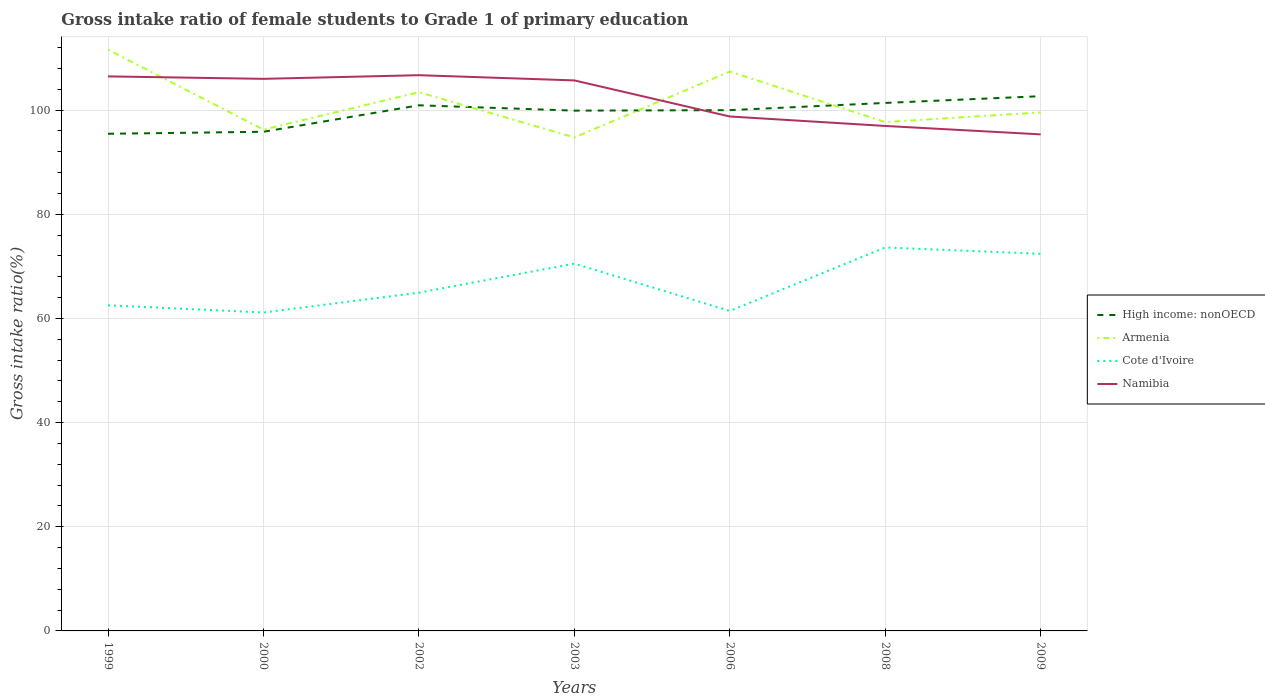How many different coloured lines are there?
Your answer should be compact. 4. Across all years, what is the maximum gross intake ratio in Namibia?
Provide a short and direct response. 95.34. In which year was the gross intake ratio in Cote d'Ivoire maximum?
Provide a short and direct response. 2000. What is the total gross intake ratio in Armenia in the graph?
Your answer should be compact. -3.97. What is the difference between the highest and the second highest gross intake ratio in High income: nonOECD?
Keep it short and to the point. 7.22. Is the gross intake ratio in Armenia strictly greater than the gross intake ratio in Cote d'Ivoire over the years?
Offer a very short reply. No. How many years are there in the graph?
Your answer should be compact. 7. What is the difference between two consecutive major ticks on the Y-axis?
Keep it short and to the point. 20. Are the values on the major ticks of Y-axis written in scientific E-notation?
Ensure brevity in your answer.  No. Does the graph contain any zero values?
Ensure brevity in your answer.  No. Does the graph contain grids?
Make the answer very short. Yes. Where does the legend appear in the graph?
Ensure brevity in your answer.  Center right. How many legend labels are there?
Ensure brevity in your answer.  4. What is the title of the graph?
Provide a short and direct response. Gross intake ratio of female students to Grade 1 of primary education. Does "Latin America(developing only)" appear as one of the legend labels in the graph?
Give a very brief answer. No. What is the label or title of the X-axis?
Make the answer very short. Years. What is the label or title of the Y-axis?
Your response must be concise. Gross intake ratio(%). What is the Gross intake ratio(%) in High income: nonOECD in 1999?
Provide a succinct answer. 95.45. What is the Gross intake ratio(%) of Armenia in 1999?
Ensure brevity in your answer.  111.59. What is the Gross intake ratio(%) in Cote d'Ivoire in 1999?
Your answer should be compact. 62.52. What is the Gross intake ratio(%) in Namibia in 1999?
Offer a very short reply. 106.47. What is the Gross intake ratio(%) in High income: nonOECD in 2000?
Provide a short and direct response. 95.84. What is the Gross intake ratio(%) in Armenia in 2000?
Ensure brevity in your answer.  96.25. What is the Gross intake ratio(%) of Cote d'Ivoire in 2000?
Offer a terse response. 61.14. What is the Gross intake ratio(%) of Namibia in 2000?
Offer a very short reply. 106. What is the Gross intake ratio(%) in High income: nonOECD in 2002?
Your response must be concise. 100.92. What is the Gross intake ratio(%) in Armenia in 2002?
Give a very brief answer. 103.44. What is the Gross intake ratio(%) of Cote d'Ivoire in 2002?
Ensure brevity in your answer.  64.95. What is the Gross intake ratio(%) of Namibia in 2002?
Your answer should be very brief. 106.7. What is the Gross intake ratio(%) in High income: nonOECD in 2003?
Your response must be concise. 99.9. What is the Gross intake ratio(%) in Armenia in 2003?
Your response must be concise. 94.75. What is the Gross intake ratio(%) in Cote d'Ivoire in 2003?
Your response must be concise. 70.52. What is the Gross intake ratio(%) in Namibia in 2003?
Offer a very short reply. 105.7. What is the Gross intake ratio(%) in High income: nonOECD in 2006?
Your answer should be compact. 99.99. What is the Gross intake ratio(%) in Armenia in 2006?
Offer a terse response. 107.41. What is the Gross intake ratio(%) of Cote d'Ivoire in 2006?
Give a very brief answer. 61.44. What is the Gross intake ratio(%) of Namibia in 2006?
Make the answer very short. 98.77. What is the Gross intake ratio(%) in High income: nonOECD in 2008?
Ensure brevity in your answer.  101.38. What is the Gross intake ratio(%) in Armenia in 2008?
Provide a short and direct response. 97.7. What is the Gross intake ratio(%) of Cote d'Ivoire in 2008?
Your answer should be compact. 73.63. What is the Gross intake ratio(%) in Namibia in 2008?
Your answer should be compact. 96.95. What is the Gross intake ratio(%) in High income: nonOECD in 2009?
Keep it short and to the point. 102.67. What is the Gross intake ratio(%) of Armenia in 2009?
Ensure brevity in your answer.  99.56. What is the Gross intake ratio(%) in Cote d'Ivoire in 2009?
Offer a terse response. 72.4. What is the Gross intake ratio(%) in Namibia in 2009?
Keep it short and to the point. 95.34. Across all years, what is the maximum Gross intake ratio(%) in High income: nonOECD?
Make the answer very short. 102.67. Across all years, what is the maximum Gross intake ratio(%) of Armenia?
Your response must be concise. 111.59. Across all years, what is the maximum Gross intake ratio(%) in Cote d'Ivoire?
Your answer should be very brief. 73.63. Across all years, what is the maximum Gross intake ratio(%) of Namibia?
Provide a succinct answer. 106.7. Across all years, what is the minimum Gross intake ratio(%) of High income: nonOECD?
Provide a succinct answer. 95.45. Across all years, what is the minimum Gross intake ratio(%) in Armenia?
Offer a terse response. 94.75. Across all years, what is the minimum Gross intake ratio(%) in Cote d'Ivoire?
Your answer should be very brief. 61.14. Across all years, what is the minimum Gross intake ratio(%) of Namibia?
Make the answer very short. 95.34. What is the total Gross intake ratio(%) in High income: nonOECD in the graph?
Ensure brevity in your answer.  696.15. What is the total Gross intake ratio(%) in Armenia in the graph?
Make the answer very short. 710.7. What is the total Gross intake ratio(%) of Cote d'Ivoire in the graph?
Your answer should be very brief. 466.6. What is the total Gross intake ratio(%) of Namibia in the graph?
Offer a very short reply. 715.94. What is the difference between the Gross intake ratio(%) in High income: nonOECD in 1999 and that in 2000?
Keep it short and to the point. -0.39. What is the difference between the Gross intake ratio(%) of Armenia in 1999 and that in 2000?
Give a very brief answer. 15.34. What is the difference between the Gross intake ratio(%) of Cote d'Ivoire in 1999 and that in 2000?
Your answer should be very brief. 1.39. What is the difference between the Gross intake ratio(%) of Namibia in 1999 and that in 2000?
Give a very brief answer. 0.47. What is the difference between the Gross intake ratio(%) of High income: nonOECD in 1999 and that in 2002?
Your answer should be compact. -5.47. What is the difference between the Gross intake ratio(%) of Armenia in 1999 and that in 2002?
Provide a short and direct response. 8.15. What is the difference between the Gross intake ratio(%) in Cote d'Ivoire in 1999 and that in 2002?
Keep it short and to the point. -2.42. What is the difference between the Gross intake ratio(%) in Namibia in 1999 and that in 2002?
Ensure brevity in your answer.  -0.23. What is the difference between the Gross intake ratio(%) in High income: nonOECD in 1999 and that in 2003?
Give a very brief answer. -4.44. What is the difference between the Gross intake ratio(%) of Armenia in 1999 and that in 2003?
Make the answer very short. 16.84. What is the difference between the Gross intake ratio(%) of Cote d'Ivoire in 1999 and that in 2003?
Ensure brevity in your answer.  -8. What is the difference between the Gross intake ratio(%) in Namibia in 1999 and that in 2003?
Your response must be concise. 0.77. What is the difference between the Gross intake ratio(%) in High income: nonOECD in 1999 and that in 2006?
Give a very brief answer. -4.54. What is the difference between the Gross intake ratio(%) in Armenia in 1999 and that in 2006?
Your response must be concise. 4.19. What is the difference between the Gross intake ratio(%) of Cote d'Ivoire in 1999 and that in 2006?
Offer a terse response. 1.08. What is the difference between the Gross intake ratio(%) in Namibia in 1999 and that in 2006?
Provide a succinct answer. 7.7. What is the difference between the Gross intake ratio(%) of High income: nonOECD in 1999 and that in 2008?
Provide a succinct answer. -5.92. What is the difference between the Gross intake ratio(%) in Armenia in 1999 and that in 2008?
Give a very brief answer. 13.89. What is the difference between the Gross intake ratio(%) of Cote d'Ivoire in 1999 and that in 2008?
Give a very brief answer. -11.1. What is the difference between the Gross intake ratio(%) in Namibia in 1999 and that in 2008?
Provide a succinct answer. 9.52. What is the difference between the Gross intake ratio(%) in High income: nonOECD in 1999 and that in 2009?
Give a very brief answer. -7.22. What is the difference between the Gross intake ratio(%) in Armenia in 1999 and that in 2009?
Ensure brevity in your answer.  12.04. What is the difference between the Gross intake ratio(%) of Cote d'Ivoire in 1999 and that in 2009?
Ensure brevity in your answer.  -9.88. What is the difference between the Gross intake ratio(%) in Namibia in 1999 and that in 2009?
Provide a succinct answer. 11.13. What is the difference between the Gross intake ratio(%) in High income: nonOECD in 2000 and that in 2002?
Your answer should be very brief. -5.08. What is the difference between the Gross intake ratio(%) in Armenia in 2000 and that in 2002?
Provide a succinct answer. -7.19. What is the difference between the Gross intake ratio(%) of Cote d'Ivoire in 2000 and that in 2002?
Offer a very short reply. -3.81. What is the difference between the Gross intake ratio(%) in Namibia in 2000 and that in 2002?
Your answer should be compact. -0.7. What is the difference between the Gross intake ratio(%) of High income: nonOECD in 2000 and that in 2003?
Keep it short and to the point. -4.06. What is the difference between the Gross intake ratio(%) in Armenia in 2000 and that in 2003?
Your answer should be very brief. 1.5. What is the difference between the Gross intake ratio(%) in Cote d'Ivoire in 2000 and that in 2003?
Your answer should be very brief. -9.39. What is the difference between the Gross intake ratio(%) of Namibia in 2000 and that in 2003?
Your response must be concise. 0.3. What is the difference between the Gross intake ratio(%) in High income: nonOECD in 2000 and that in 2006?
Provide a short and direct response. -4.15. What is the difference between the Gross intake ratio(%) of Armenia in 2000 and that in 2006?
Keep it short and to the point. -11.15. What is the difference between the Gross intake ratio(%) of Cote d'Ivoire in 2000 and that in 2006?
Give a very brief answer. -0.31. What is the difference between the Gross intake ratio(%) in Namibia in 2000 and that in 2006?
Provide a short and direct response. 7.23. What is the difference between the Gross intake ratio(%) of High income: nonOECD in 2000 and that in 2008?
Your answer should be compact. -5.54. What is the difference between the Gross intake ratio(%) in Armenia in 2000 and that in 2008?
Make the answer very short. -1.45. What is the difference between the Gross intake ratio(%) of Cote d'Ivoire in 2000 and that in 2008?
Make the answer very short. -12.49. What is the difference between the Gross intake ratio(%) of Namibia in 2000 and that in 2008?
Your answer should be very brief. 9.05. What is the difference between the Gross intake ratio(%) in High income: nonOECD in 2000 and that in 2009?
Your response must be concise. -6.83. What is the difference between the Gross intake ratio(%) in Armenia in 2000 and that in 2009?
Your response must be concise. -3.3. What is the difference between the Gross intake ratio(%) in Cote d'Ivoire in 2000 and that in 2009?
Provide a succinct answer. -11.27. What is the difference between the Gross intake ratio(%) in Namibia in 2000 and that in 2009?
Provide a succinct answer. 10.66. What is the difference between the Gross intake ratio(%) in High income: nonOECD in 2002 and that in 2003?
Offer a very short reply. 1.02. What is the difference between the Gross intake ratio(%) in Armenia in 2002 and that in 2003?
Give a very brief answer. 8.69. What is the difference between the Gross intake ratio(%) of Cote d'Ivoire in 2002 and that in 2003?
Provide a succinct answer. -5.58. What is the difference between the Gross intake ratio(%) in High income: nonOECD in 2002 and that in 2006?
Make the answer very short. 0.93. What is the difference between the Gross intake ratio(%) in Armenia in 2002 and that in 2006?
Give a very brief answer. -3.97. What is the difference between the Gross intake ratio(%) of Cote d'Ivoire in 2002 and that in 2006?
Make the answer very short. 3.5. What is the difference between the Gross intake ratio(%) of Namibia in 2002 and that in 2006?
Offer a very short reply. 7.93. What is the difference between the Gross intake ratio(%) in High income: nonOECD in 2002 and that in 2008?
Your answer should be compact. -0.45. What is the difference between the Gross intake ratio(%) of Armenia in 2002 and that in 2008?
Your answer should be very brief. 5.74. What is the difference between the Gross intake ratio(%) of Cote d'Ivoire in 2002 and that in 2008?
Your answer should be compact. -8.68. What is the difference between the Gross intake ratio(%) in Namibia in 2002 and that in 2008?
Keep it short and to the point. 9.75. What is the difference between the Gross intake ratio(%) of High income: nonOECD in 2002 and that in 2009?
Offer a terse response. -1.75. What is the difference between the Gross intake ratio(%) of Armenia in 2002 and that in 2009?
Your answer should be compact. 3.89. What is the difference between the Gross intake ratio(%) in Cote d'Ivoire in 2002 and that in 2009?
Offer a terse response. -7.46. What is the difference between the Gross intake ratio(%) of Namibia in 2002 and that in 2009?
Your answer should be compact. 11.36. What is the difference between the Gross intake ratio(%) of High income: nonOECD in 2003 and that in 2006?
Provide a short and direct response. -0.09. What is the difference between the Gross intake ratio(%) in Armenia in 2003 and that in 2006?
Your answer should be compact. -12.66. What is the difference between the Gross intake ratio(%) in Cote d'Ivoire in 2003 and that in 2006?
Your answer should be very brief. 9.08. What is the difference between the Gross intake ratio(%) of Namibia in 2003 and that in 2006?
Ensure brevity in your answer.  6.93. What is the difference between the Gross intake ratio(%) in High income: nonOECD in 2003 and that in 2008?
Your response must be concise. -1.48. What is the difference between the Gross intake ratio(%) of Armenia in 2003 and that in 2008?
Your answer should be compact. -2.95. What is the difference between the Gross intake ratio(%) of Cote d'Ivoire in 2003 and that in 2008?
Your answer should be compact. -3.1. What is the difference between the Gross intake ratio(%) in Namibia in 2003 and that in 2008?
Keep it short and to the point. 8.74. What is the difference between the Gross intake ratio(%) in High income: nonOECD in 2003 and that in 2009?
Give a very brief answer. -2.77. What is the difference between the Gross intake ratio(%) in Armenia in 2003 and that in 2009?
Provide a succinct answer. -4.81. What is the difference between the Gross intake ratio(%) of Cote d'Ivoire in 2003 and that in 2009?
Give a very brief answer. -1.88. What is the difference between the Gross intake ratio(%) of Namibia in 2003 and that in 2009?
Your response must be concise. 10.36. What is the difference between the Gross intake ratio(%) in High income: nonOECD in 2006 and that in 2008?
Offer a terse response. -1.39. What is the difference between the Gross intake ratio(%) of Armenia in 2006 and that in 2008?
Make the answer very short. 9.71. What is the difference between the Gross intake ratio(%) of Cote d'Ivoire in 2006 and that in 2008?
Ensure brevity in your answer.  -12.18. What is the difference between the Gross intake ratio(%) of Namibia in 2006 and that in 2008?
Your response must be concise. 1.82. What is the difference between the Gross intake ratio(%) in High income: nonOECD in 2006 and that in 2009?
Provide a succinct answer. -2.68. What is the difference between the Gross intake ratio(%) in Armenia in 2006 and that in 2009?
Offer a very short reply. 7.85. What is the difference between the Gross intake ratio(%) of Cote d'Ivoire in 2006 and that in 2009?
Your response must be concise. -10.96. What is the difference between the Gross intake ratio(%) in Namibia in 2006 and that in 2009?
Provide a short and direct response. 3.43. What is the difference between the Gross intake ratio(%) of High income: nonOECD in 2008 and that in 2009?
Ensure brevity in your answer.  -1.29. What is the difference between the Gross intake ratio(%) of Armenia in 2008 and that in 2009?
Your answer should be compact. -1.85. What is the difference between the Gross intake ratio(%) in Cote d'Ivoire in 2008 and that in 2009?
Give a very brief answer. 1.22. What is the difference between the Gross intake ratio(%) of Namibia in 2008 and that in 2009?
Your response must be concise. 1.62. What is the difference between the Gross intake ratio(%) of High income: nonOECD in 1999 and the Gross intake ratio(%) of Armenia in 2000?
Your answer should be compact. -0.8. What is the difference between the Gross intake ratio(%) in High income: nonOECD in 1999 and the Gross intake ratio(%) in Cote d'Ivoire in 2000?
Your answer should be very brief. 34.32. What is the difference between the Gross intake ratio(%) in High income: nonOECD in 1999 and the Gross intake ratio(%) in Namibia in 2000?
Your answer should be compact. -10.55. What is the difference between the Gross intake ratio(%) in Armenia in 1999 and the Gross intake ratio(%) in Cote d'Ivoire in 2000?
Your answer should be very brief. 50.46. What is the difference between the Gross intake ratio(%) of Armenia in 1999 and the Gross intake ratio(%) of Namibia in 2000?
Offer a very short reply. 5.59. What is the difference between the Gross intake ratio(%) in Cote d'Ivoire in 1999 and the Gross intake ratio(%) in Namibia in 2000?
Provide a succinct answer. -43.48. What is the difference between the Gross intake ratio(%) in High income: nonOECD in 1999 and the Gross intake ratio(%) in Armenia in 2002?
Your answer should be very brief. -7.99. What is the difference between the Gross intake ratio(%) of High income: nonOECD in 1999 and the Gross intake ratio(%) of Cote d'Ivoire in 2002?
Provide a short and direct response. 30.51. What is the difference between the Gross intake ratio(%) of High income: nonOECD in 1999 and the Gross intake ratio(%) of Namibia in 2002?
Offer a very short reply. -11.25. What is the difference between the Gross intake ratio(%) in Armenia in 1999 and the Gross intake ratio(%) in Cote d'Ivoire in 2002?
Offer a very short reply. 46.65. What is the difference between the Gross intake ratio(%) in Armenia in 1999 and the Gross intake ratio(%) in Namibia in 2002?
Provide a short and direct response. 4.89. What is the difference between the Gross intake ratio(%) in Cote d'Ivoire in 1999 and the Gross intake ratio(%) in Namibia in 2002?
Make the answer very short. -44.18. What is the difference between the Gross intake ratio(%) of High income: nonOECD in 1999 and the Gross intake ratio(%) of Armenia in 2003?
Your response must be concise. 0.7. What is the difference between the Gross intake ratio(%) in High income: nonOECD in 1999 and the Gross intake ratio(%) in Cote d'Ivoire in 2003?
Your answer should be compact. 24.93. What is the difference between the Gross intake ratio(%) of High income: nonOECD in 1999 and the Gross intake ratio(%) of Namibia in 2003?
Your answer should be compact. -10.25. What is the difference between the Gross intake ratio(%) of Armenia in 1999 and the Gross intake ratio(%) of Cote d'Ivoire in 2003?
Offer a terse response. 41.07. What is the difference between the Gross intake ratio(%) of Armenia in 1999 and the Gross intake ratio(%) of Namibia in 2003?
Provide a succinct answer. 5.89. What is the difference between the Gross intake ratio(%) of Cote d'Ivoire in 1999 and the Gross intake ratio(%) of Namibia in 2003?
Provide a short and direct response. -43.18. What is the difference between the Gross intake ratio(%) of High income: nonOECD in 1999 and the Gross intake ratio(%) of Armenia in 2006?
Your answer should be very brief. -11.95. What is the difference between the Gross intake ratio(%) of High income: nonOECD in 1999 and the Gross intake ratio(%) of Cote d'Ivoire in 2006?
Provide a short and direct response. 34.01. What is the difference between the Gross intake ratio(%) in High income: nonOECD in 1999 and the Gross intake ratio(%) in Namibia in 2006?
Provide a short and direct response. -3.32. What is the difference between the Gross intake ratio(%) in Armenia in 1999 and the Gross intake ratio(%) in Cote d'Ivoire in 2006?
Ensure brevity in your answer.  50.15. What is the difference between the Gross intake ratio(%) of Armenia in 1999 and the Gross intake ratio(%) of Namibia in 2006?
Offer a very short reply. 12.82. What is the difference between the Gross intake ratio(%) in Cote d'Ivoire in 1999 and the Gross intake ratio(%) in Namibia in 2006?
Ensure brevity in your answer.  -36.25. What is the difference between the Gross intake ratio(%) of High income: nonOECD in 1999 and the Gross intake ratio(%) of Armenia in 2008?
Your answer should be compact. -2.25. What is the difference between the Gross intake ratio(%) in High income: nonOECD in 1999 and the Gross intake ratio(%) in Cote d'Ivoire in 2008?
Give a very brief answer. 21.83. What is the difference between the Gross intake ratio(%) in High income: nonOECD in 1999 and the Gross intake ratio(%) in Namibia in 2008?
Offer a very short reply. -1.5. What is the difference between the Gross intake ratio(%) of Armenia in 1999 and the Gross intake ratio(%) of Cote d'Ivoire in 2008?
Offer a very short reply. 37.97. What is the difference between the Gross intake ratio(%) in Armenia in 1999 and the Gross intake ratio(%) in Namibia in 2008?
Provide a succinct answer. 14.64. What is the difference between the Gross intake ratio(%) in Cote d'Ivoire in 1999 and the Gross intake ratio(%) in Namibia in 2008?
Offer a terse response. -34.43. What is the difference between the Gross intake ratio(%) of High income: nonOECD in 1999 and the Gross intake ratio(%) of Armenia in 2009?
Offer a terse response. -4.1. What is the difference between the Gross intake ratio(%) in High income: nonOECD in 1999 and the Gross intake ratio(%) in Cote d'Ivoire in 2009?
Give a very brief answer. 23.05. What is the difference between the Gross intake ratio(%) in High income: nonOECD in 1999 and the Gross intake ratio(%) in Namibia in 2009?
Offer a terse response. 0.11. What is the difference between the Gross intake ratio(%) of Armenia in 1999 and the Gross intake ratio(%) of Cote d'Ivoire in 2009?
Your answer should be compact. 39.19. What is the difference between the Gross intake ratio(%) in Armenia in 1999 and the Gross intake ratio(%) in Namibia in 2009?
Keep it short and to the point. 16.25. What is the difference between the Gross intake ratio(%) in Cote d'Ivoire in 1999 and the Gross intake ratio(%) in Namibia in 2009?
Give a very brief answer. -32.82. What is the difference between the Gross intake ratio(%) in High income: nonOECD in 2000 and the Gross intake ratio(%) in Armenia in 2002?
Your response must be concise. -7.6. What is the difference between the Gross intake ratio(%) of High income: nonOECD in 2000 and the Gross intake ratio(%) of Cote d'Ivoire in 2002?
Provide a succinct answer. 30.89. What is the difference between the Gross intake ratio(%) of High income: nonOECD in 2000 and the Gross intake ratio(%) of Namibia in 2002?
Your answer should be compact. -10.86. What is the difference between the Gross intake ratio(%) in Armenia in 2000 and the Gross intake ratio(%) in Cote d'Ivoire in 2002?
Make the answer very short. 31.31. What is the difference between the Gross intake ratio(%) in Armenia in 2000 and the Gross intake ratio(%) in Namibia in 2002?
Your answer should be compact. -10.45. What is the difference between the Gross intake ratio(%) of Cote d'Ivoire in 2000 and the Gross intake ratio(%) of Namibia in 2002?
Provide a short and direct response. -45.57. What is the difference between the Gross intake ratio(%) in High income: nonOECD in 2000 and the Gross intake ratio(%) in Armenia in 2003?
Provide a short and direct response. 1.09. What is the difference between the Gross intake ratio(%) in High income: nonOECD in 2000 and the Gross intake ratio(%) in Cote d'Ivoire in 2003?
Offer a terse response. 25.32. What is the difference between the Gross intake ratio(%) of High income: nonOECD in 2000 and the Gross intake ratio(%) of Namibia in 2003?
Your response must be concise. -9.86. What is the difference between the Gross intake ratio(%) in Armenia in 2000 and the Gross intake ratio(%) in Cote d'Ivoire in 2003?
Your response must be concise. 25.73. What is the difference between the Gross intake ratio(%) of Armenia in 2000 and the Gross intake ratio(%) of Namibia in 2003?
Your answer should be very brief. -9.45. What is the difference between the Gross intake ratio(%) of Cote d'Ivoire in 2000 and the Gross intake ratio(%) of Namibia in 2003?
Your response must be concise. -44.56. What is the difference between the Gross intake ratio(%) of High income: nonOECD in 2000 and the Gross intake ratio(%) of Armenia in 2006?
Offer a very short reply. -11.57. What is the difference between the Gross intake ratio(%) in High income: nonOECD in 2000 and the Gross intake ratio(%) in Cote d'Ivoire in 2006?
Your answer should be compact. 34.4. What is the difference between the Gross intake ratio(%) of High income: nonOECD in 2000 and the Gross intake ratio(%) of Namibia in 2006?
Provide a short and direct response. -2.93. What is the difference between the Gross intake ratio(%) in Armenia in 2000 and the Gross intake ratio(%) in Cote d'Ivoire in 2006?
Offer a very short reply. 34.81. What is the difference between the Gross intake ratio(%) of Armenia in 2000 and the Gross intake ratio(%) of Namibia in 2006?
Provide a short and direct response. -2.52. What is the difference between the Gross intake ratio(%) in Cote d'Ivoire in 2000 and the Gross intake ratio(%) in Namibia in 2006?
Make the answer very short. -37.64. What is the difference between the Gross intake ratio(%) in High income: nonOECD in 2000 and the Gross intake ratio(%) in Armenia in 2008?
Make the answer very short. -1.86. What is the difference between the Gross intake ratio(%) of High income: nonOECD in 2000 and the Gross intake ratio(%) of Cote d'Ivoire in 2008?
Offer a terse response. 22.21. What is the difference between the Gross intake ratio(%) of High income: nonOECD in 2000 and the Gross intake ratio(%) of Namibia in 2008?
Make the answer very short. -1.11. What is the difference between the Gross intake ratio(%) of Armenia in 2000 and the Gross intake ratio(%) of Cote d'Ivoire in 2008?
Your answer should be compact. 22.63. What is the difference between the Gross intake ratio(%) in Armenia in 2000 and the Gross intake ratio(%) in Namibia in 2008?
Ensure brevity in your answer.  -0.7. What is the difference between the Gross intake ratio(%) of Cote d'Ivoire in 2000 and the Gross intake ratio(%) of Namibia in 2008?
Make the answer very short. -35.82. What is the difference between the Gross intake ratio(%) in High income: nonOECD in 2000 and the Gross intake ratio(%) in Armenia in 2009?
Provide a succinct answer. -3.72. What is the difference between the Gross intake ratio(%) in High income: nonOECD in 2000 and the Gross intake ratio(%) in Cote d'Ivoire in 2009?
Make the answer very short. 23.44. What is the difference between the Gross intake ratio(%) in High income: nonOECD in 2000 and the Gross intake ratio(%) in Namibia in 2009?
Your answer should be compact. 0.5. What is the difference between the Gross intake ratio(%) of Armenia in 2000 and the Gross intake ratio(%) of Cote d'Ivoire in 2009?
Give a very brief answer. 23.85. What is the difference between the Gross intake ratio(%) of Armenia in 2000 and the Gross intake ratio(%) of Namibia in 2009?
Give a very brief answer. 0.91. What is the difference between the Gross intake ratio(%) in Cote d'Ivoire in 2000 and the Gross intake ratio(%) in Namibia in 2009?
Offer a very short reply. -34.2. What is the difference between the Gross intake ratio(%) of High income: nonOECD in 2002 and the Gross intake ratio(%) of Armenia in 2003?
Your answer should be very brief. 6.17. What is the difference between the Gross intake ratio(%) in High income: nonOECD in 2002 and the Gross intake ratio(%) in Cote d'Ivoire in 2003?
Keep it short and to the point. 30.4. What is the difference between the Gross intake ratio(%) of High income: nonOECD in 2002 and the Gross intake ratio(%) of Namibia in 2003?
Provide a short and direct response. -4.78. What is the difference between the Gross intake ratio(%) in Armenia in 2002 and the Gross intake ratio(%) in Cote d'Ivoire in 2003?
Ensure brevity in your answer.  32.92. What is the difference between the Gross intake ratio(%) of Armenia in 2002 and the Gross intake ratio(%) of Namibia in 2003?
Provide a succinct answer. -2.26. What is the difference between the Gross intake ratio(%) in Cote d'Ivoire in 2002 and the Gross intake ratio(%) in Namibia in 2003?
Keep it short and to the point. -40.75. What is the difference between the Gross intake ratio(%) of High income: nonOECD in 2002 and the Gross intake ratio(%) of Armenia in 2006?
Give a very brief answer. -6.49. What is the difference between the Gross intake ratio(%) of High income: nonOECD in 2002 and the Gross intake ratio(%) of Cote d'Ivoire in 2006?
Make the answer very short. 39.48. What is the difference between the Gross intake ratio(%) in High income: nonOECD in 2002 and the Gross intake ratio(%) in Namibia in 2006?
Provide a succinct answer. 2.15. What is the difference between the Gross intake ratio(%) of Armenia in 2002 and the Gross intake ratio(%) of Cote d'Ivoire in 2006?
Your response must be concise. 42. What is the difference between the Gross intake ratio(%) of Armenia in 2002 and the Gross intake ratio(%) of Namibia in 2006?
Ensure brevity in your answer.  4.67. What is the difference between the Gross intake ratio(%) of Cote d'Ivoire in 2002 and the Gross intake ratio(%) of Namibia in 2006?
Give a very brief answer. -33.83. What is the difference between the Gross intake ratio(%) in High income: nonOECD in 2002 and the Gross intake ratio(%) in Armenia in 2008?
Your answer should be compact. 3.22. What is the difference between the Gross intake ratio(%) of High income: nonOECD in 2002 and the Gross intake ratio(%) of Cote d'Ivoire in 2008?
Make the answer very short. 27.3. What is the difference between the Gross intake ratio(%) of High income: nonOECD in 2002 and the Gross intake ratio(%) of Namibia in 2008?
Provide a succinct answer. 3.97. What is the difference between the Gross intake ratio(%) in Armenia in 2002 and the Gross intake ratio(%) in Cote d'Ivoire in 2008?
Your answer should be compact. 29.82. What is the difference between the Gross intake ratio(%) in Armenia in 2002 and the Gross intake ratio(%) in Namibia in 2008?
Keep it short and to the point. 6.49. What is the difference between the Gross intake ratio(%) in Cote d'Ivoire in 2002 and the Gross intake ratio(%) in Namibia in 2008?
Provide a succinct answer. -32.01. What is the difference between the Gross intake ratio(%) in High income: nonOECD in 2002 and the Gross intake ratio(%) in Armenia in 2009?
Your answer should be very brief. 1.37. What is the difference between the Gross intake ratio(%) in High income: nonOECD in 2002 and the Gross intake ratio(%) in Cote d'Ivoire in 2009?
Ensure brevity in your answer.  28.52. What is the difference between the Gross intake ratio(%) of High income: nonOECD in 2002 and the Gross intake ratio(%) of Namibia in 2009?
Offer a very short reply. 5.58. What is the difference between the Gross intake ratio(%) in Armenia in 2002 and the Gross intake ratio(%) in Cote d'Ivoire in 2009?
Keep it short and to the point. 31.04. What is the difference between the Gross intake ratio(%) in Armenia in 2002 and the Gross intake ratio(%) in Namibia in 2009?
Your answer should be very brief. 8.1. What is the difference between the Gross intake ratio(%) in Cote d'Ivoire in 2002 and the Gross intake ratio(%) in Namibia in 2009?
Provide a succinct answer. -30.39. What is the difference between the Gross intake ratio(%) of High income: nonOECD in 2003 and the Gross intake ratio(%) of Armenia in 2006?
Offer a very short reply. -7.51. What is the difference between the Gross intake ratio(%) in High income: nonOECD in 2003 and the Gross intake ratio(%) in Cote d'Ivoire in 2006?
Your answer should be compact. 38.46. What is the difference between the Gross intake ratio(%) of High income: nonOECD in 2003 and the Gross intake ratio(%) of Namibia in 2006?
Provide a succinct answer. 1.12. What is the difference between the Gross intake ratio(%) in Armenia in 2003 and the Gross intake ratio(%) in Cote d'Ivoire in 2006?
Keep it short and to the point. 33.31. What is the difference between the Gross intake ratio(%) of Armenia in 2003 and the Gross intake ratio(%) of Namibia in 2006?
Keep it short and to the point. -4.02. What is the difference between the Gross intake ratio(%) of Cote d'Ivoire in 2003 and the Gross intake ratio(%) of Namibia in 2006?
Make the answer very short. -28.25. What is the difference between the Gross intake ratio(%) in High income: nonOECD in 2003 and the Gross intake ratio(%) in Armenia in 2008?
Make the answer very short. 2.2. What is the difference between the Gross intake ratio(%) of High income: nonOECD in 2003 and the Gross intake ratio(%) of Cote d'Ivoire in 2008?
Make the answer very short. 26.27. What is the difference between the Gross intake ratio(%) in High income: nonOECD in 2003 and the Gross intake ratio(%) in Namibia in 2008?
Offer a very short reply. 2.94. What is the difference between the Gross intake ratio(%) of Armenia in 2003 and the Gross intake ratio(%) of Cote d'Ivoire in 2008?
Keep it short and to the point. 21.12. What is the difference between the Gross intake ratio(%) in Armenia in 2003 and the Gross intake ratio(%) in Namibia in 2008?
Provide a short and direct response. -2.21. What is the difference between the Gross intake ratio(%) of Cote d'Ivoire in 2003 and the Gross intake ratio(%) of Namibia in 2008?
Keep it short and to the point. -26.43. What is the difference between the Gross intake ratio(%) of High income: nonOECD in 2003 and the Gross intake ratio(%) of Armenia in 2009?
Provide a short and direct response. 0.34. What is the difference between the Gross intake ratio(%) of High income: nonOECD in 2003 and the Gross intake ratio(%) of Cote d'Ivoire in 2009?
Provide a succinct answer. 27.5. What is the difference between the Gross intake ratio(%) in High income: nonOECD in 2003 and the Gross intake ratio(%) in Namibia in 2009?
Keep it short and to the point. 4.56. What is the difference between the Gross intake ratio(%) in Armenia in 2003 and the Gross intake ratio(%) in Cote d'Ivoire in 2009?
Offer a terse response. 22.35. What is the difference between the Gross intake ratio(%) of Armenia in 2003 and the Gross intake ratio(%) of Namibia in 2009?
Give a very brief answer. -0.59. What is the difference between the Gross intake ratio(%) in Cote d'Ivoire in 2003 and the Gross intake ratio(%) in Namibia in 2009?
Make the answer very short. -24.82. What is the difference between the Gross intake ratio(%) in High income: nonOECD in 2006 and the Gross intake ratio(%) in Armenia in 2008?
Provide a succinct answer. 2.29. What is the difference between the Gross intake ratio(%) of High income: nonOECD in 2006 and the Gross intake ratio(%) of Cote d'Ivoire in 2008?
Provide a succinct answer. 26.36. What is the difference between the Gross intake ratio(%) in High income: nonOECD in 2006 and the Gross intake ratio(%) in Namibia in 2008?
Your response must be concise. 3.04. What is the difference between the Gross intake ratio(%) of Armenia in 2006 and the Gross intake ratio(%) of Cote d'Ivoire in 2008?
Keep it short and to the point. 33.78. What is the difference between the Gross intake ratio(%) of Armenia in 2006 and the Gross intake ratio(%) of Namibia in 2008?
Keep it short and to the point. 10.45. What is the difference between the Gross intake ratio(%) in Cote d'Ivoire in 2006 and the Gross intake ratio(%) in Namibia in 2008?
Offer a terse response. -35.51. What is the difference between the Gross intake ratio(%) of High income: nonOECD in 2006 and the Gross intake ratio(%) of Armenia in 2009?
Give a very brief answer. 0.43. What is the difference between the Gross intake ratio(%) of High income: nonOECD in 2006 and the Gross intake ratio(%) of Cote d'Ivoire in 2009?
Provide a short and direct response. 27.59. What is the difference between the Gross intake ratio(%) in High income: nonOECD in 2006 and the Gross intake ratio(%) in Namibia in 2009?
Keep it short and to the point. 4.65. What is the difference between the Gross intake ratio(%) in Armenia in 2006 and the Gross intake ratio(%) in Cote d'Ivoire in 2009?
Your response must be concise. 35.01. What is the difference between the Gross intake ratio(%) of Armenia in 2006 and the Gross intake ratio(%) of Namibia in 2009?
Keep it short and to the point. 12.07. What is the difference between the Gross intake ratio(%) in Cote d'Ivoire in 2006 and the Gross intake ratio(%) in Namibia in 2009?
Ensure brevity in your answer.  -33.9. What is the difference between the Gross intake ratio(%) of High income: nonOECD in 2008 and the Gross intake ratio(%) of Armenia in 2009?
Ensure brevity in your answer.  1.82. What is the difference between the Gross intake ratio(%) of High income: nonOECD in 2008 and the Gross intake ratio(%) of Cote d'Ivoire in 2009?
Provide a short and direct response. 28.97. What is the difference between the Gross intake ratio(%) in High income: nonOECD in 2008 and the Gross intake ratio(%) in Namibia in 2009?
Provide a succinct answer. 6.04. What is the difference between the Gross intake ratio(%) in Armenia in 2008 and the Gross intake ratio(%) in Cote d'Ivoire in 2009?
Offer a terse response. 25.3. What is the difference between the Gross intake ratio(%) of Armenia in 2008 and the Gross intake ratio(%) of Namibia in 2009?
Make the answer very short. 2.36. What is the difference between the Gross intake ratio(%) of Cote d'Ivoire in 2008 and the Gross intake ratio(%) of Namibia in 2009?
Provide a short and direct response. -21.71. What is the average Gross intake ratio(%) in High income: nonOECD per year?
Give a very brief answer. 99.45. What is the average Gross intake ratio(%) in Armenia per year?
Your answer should be very brief. 101.53. What is the average Gross intake ratio(%) of Cote d'Ivoire per year?
Your answer should be very brief. 66.66. What is the average Gross intake ratio(%) of Namibia per year?
Your answer should be very brief. 102.28. In the year 1999, what is the difference between the Gross intake ratio(%) of High income: nonOECD and Gross intake ratio(%) of Armenia?
Provide a short and direct response. -16.14. In the year 1999, what is the difference between the Gross intake ratio(%) in High income: nonOECD and Gross intake ratio(%) in Cote d'Ivoire?
Your answer should be compact. 32.93. In the year 1999, what is the difference between the Gross intake ratio(%) of High income: nonOECD and Gross intake ratio(%) of Namibia?
Your response must be concise. -11.02. In the year 1999, what is the difference between the Gross intake ratio(%) in Armenia and Gross intake ratio(%) in Cote d'Ivoire?
Provide a short and direct response. 49.07. In the year 1999, what is the difference between the Gross intake ratio(%) of Armenia and Gross intake ratio(%) of Namibia?
Your answer should be compact. 5.12. In the year 1999, what is the difference between the Gross intake ratio(%) of Cote d'Ivoire and Gross intake ratio(%) of Namibia?
Make the answer very short. -43.95. In the year 2000, what is the difference between the Gross intake ratio(%) of High income: nonOECD and Gross intake ratio(%) of Armenia?
Your answer should be very brief. -0.41. In the year 2000, what is the difference between the Gross intake ratio(%) of High income: nonOECD and Gross intake ratio(%) of Cote d'Ivoire?
Offer a terse response. 34.7. In the year 2000, what is the difference between the Gross intake ratio(%) in High income: nonOECD and Gross intake ratio(%) in Namibia?
Offer a very short reply. -10.16. In the year 2000, what is the difference between the Gross intake ratio(%) in Armenia and Gross intake ratio(%) in Cote d'Ivoire?
Ensure brevity in your answer.  35.12. In the year 2000, what is the difference between the Gross intake ratio(%) in Armenia and Gross intake ratio(%) in Namibia?
Provide a succinct answer. -9.75. In the year 2000, what is the difference between the Gross intake ratio(%) in Cote d'Ivoire and Gross intake ratio(%) in Namibia?
Keep it short and to the point. -44.86. In the year 2002, what is the difference between the Gross intake ratio(%) of High income: nonOECD and Gross intake ratio(%) of Armenia?
Your answer should be compact. -2.52. In the year 2002, what is the difference between the Gross intake ratio(%) in High income: nonOECD and Gross intake ratio(%) in Cote d'Ivoire?
Your response must be concise. 35.98. In the year 2002, what is the difference between the Gross intake ratio(%) of High income: nonOECD and Gross intake ratio(%) of Namibia?
Your response must be concise. -5.78. In the year 2002, what is the difference between the Gross intake ratio(%) in Armenia and Gross intake ratio(%) in Cote d'Ivoire?
Provide a short and direct response. 38.5. In the year 2002, what is the difference between the Gross intake ratio(%) in Armenia and Gross intake ratio(%) in Namibia?
Your answer should be very brief. -3.26. In the year 2002, what is the difference between the Gross intake ratio(%) of Cote d'Ivoire and Gross intake ratio(%) of Namibia?
Your answer should be very brief. -41.76. In the year 2003, what is the difference between the Gross intake ratio(%) of High income: nonOECD and Gross intake ratio(%) of Armenia?
Make the answer very short. 5.15. In the year 2003, what is the difference between the Gross intake ratio(%) of High income: nonOECD and Gross intake ratio(%) of Cote d'Ivoire?
Give a very brief answer. 29.38. In the year 2003, what is the difference between the Gross intake ratio(%) of High income: nonOECD and Gross intake ratio(%) of Namibia?
Offer a terse response. -5.8. In the year 2003, what is the difference between the Gross intake ratio(%) in Armenia and Gross intake ratio(%) in Cote d'Ivoire?
Offer a terse response. 24.23. In the year 2003, what is the difference between the Gross intake ratio(%) of Armenia and Gross intake ratio(%) of Namibia?
Offer a very short reply. -10.95. In the year 2003, what is the difference between the Gross intake ratio(%) in Cote d'Ivoire and Gross intake ratio(%) in Namibia?
Offer a terse response. -35.18. In the year 2006, what is the difference between the Gross intake ratio(%) of High income: nonOECD and Gross intake ratio(%) of Armenia?
Your response must be concise. -7.42. In the year 2006, what is the difference between the Gross intake ratio(%) in High income: nonOECD and Gross intake ratio(%) in Cote d'Ivoire?
Your answer should be compact. 38.55. In the year 2006, what is the difference between the Gross intake ratio(%) in High income: nonOECD and Gross intake ratio(%) in Namibia?
Your response must be concise. 1.22. In the year 2006, what is the difference between the Gross intake ratio(%) in Armenia and Gross intake ratio(%) in Cote d'Ivoire?
Offer a very short reply. 45.97. In the year 2006, what is the difference between the Gross intake ratio(%) in Armenia and Gross intake ratio(%) in Namibia?
Offer a terse response. 8.63. In the year 2006, what is the difference between the Gross intake ratio(%) of Cote d'Ivoire and Gross intake ratio(%) of Namibia?
Your answer should be compact. -37.33. In the year 2008, what is the difference between the Gross intake ratio(%) of High income: nonOECD and Gross intake ratio(%) of Armenia?
Keep it short and to the point. 3.68. In the year 2008, what is the difference between the Gross intake ratio(%) of High income: nonOECD and Gross intake ratio(%) of Cote d'Ivoire?
Make the answer very short. 27.75. In the year 2008, what is the difference between the Gross intake ratio(%) in High income: nonOECD and Gross intake ratio(%) in Namibia?
Give a very brief answer. 4.42. In the year 2008, what is the difference between the Gross intake ratio(%) in Armenia and Gross intake ratio(%) in Cote d'Ivoire?
Your answer should be compact. 24.07. In the year 2008, what is the difference between the Gross intake ratio(%) in Armenia and Gross intake ratio(%) in Namibia?
Ensure brevity in your answer.  0.75. In the year 2008, what is the difference between the Gross intake ratio(%) in Cote d'Ivoire and Gross intake ratio(%) in Namibia?
Offer a terse response. -23.33. In the year 2009, what is the difference between the Gross intake ratio(%) in High income: nonOECD and Gross intake ratio(%) in Armenia?
Ensure brevity in your answer.  3.12. In the year 2009, what is the difference between the Gross intake ratio(%) in High income: nonOECD and Gross intake ratio(%) in Cote d'Ivoire?
Provide a short and direct response. 30.27. In the year 2009, what is the difference between the Gross intake ratio(%) in High income: nonOECD and Gross intake ratio(%) in Namibia?
Provide a short and direct response. 7.33. In the year 2009, what is the difference between the Gross intake ratio(%) of Armenia and Gross intake ratio(%) of Cote d'Ivoire?
Offer a very short reply. 27.15. In the year 2009, what is the difference between the Gross intake ratio(%) of Armenia and Gross intake ratio(%) of Namibia?
Make the answer very short. 4.22. In the year 2009, what is the difference between the Gross intake ratio(%) of Cote d'Ivoire and Gross intake ratio(%) of Namibia?
Ensure brevity in your answer.  -22.94. What is the ratio of the Gross intake ratio(%) of High income: nonOECD in 1999 to that in 2000?
Your response must be concise. 1. What is the ratio of the Gross intake ratio(%) in Armenia in 1999 to that in 2000?
Give a very brief answer. 1.16. What is the ratio of the Gross intake ratio(%) of Cote d'Ivoire in 1999 to that in 2000?
Your answer should be compact. 1.02. What is the ratio of the Gross intake ratio(%) in High income: nonOECD in 1999 to that in 2002?
Your answer should be very brief. 0.95. What is the ratio of the Gross intake ratio(%) in Armenia in 1999 to that in 2002?
Keep it short and to the point. 1.08. What is the ratio of the Gross intake ratio(%) in Cote d'Ivoire in 1999 to that in 2002?
Offer a very short reply. 0.96. What is the ratio of the Gross intake ratio(%) of High income: nonOECD in 1999 to that in 2003?
Give a very brief answer. 0.96. What is the ratio of the Gross intake ratio(%) of Armenia in 1999 to that in 2003?
Keep it short and to the point. 1.18. What is the ratio of the Gross intake ratio(%) of Cote d'Ivoire in 1999 to that in 2003?
Make the answer very short. 0.89. What is the ratio of the Gross intake ratio(%) of Namibia in 1999 to that in 2003?
Your response must be concise. 1.01. What is the ratio of the Gross intake ratio(%) of High income: nonOECD in 1999 to that in 2006?
Your answer should be very brief. 0.95. What is the ratio of the Gross intake ratio(%) in Armenia in 1999 to that in 2006?
Ensure brevity in your answer.  1.04. What is the ratio of the Gross intake ratio(%) of Cote d'Ivoire in 1999 to that in 2006?
Provide a succinct answer. 1.02. What is the ratio of the Gross intake ratio(%) in Namibia in 1999 to that in 2006?
Give a very brief answer. 1.08. What is the ratio of the Gross intake ratio(%) of High income: nonOECD in 1999 to that in 2008?
Offer a terse response. 0.94. What is the ratio of the Gross intake ratio(%) of Armenia in 1999 to that in 2008?
Your answer should be compact. 1.14. What is the ratio of the Gross intake ratio(%) in Cote d'Ivoire in 1999 to that in 2008?
Your response must be concise. 0.85. What is the ratio of the Gross intake ratio(%) of Namibia in 1999 to that in 2008?
Provide a short and direct response. 1.1. What is the ratio of the Gross intake ratio(%) in High income: nonOECD in 1999 to that in 2009?
Make the answer very short. 0.93. What is the ratio of the Gross intake ratio(%) of Armenia in 1999 to that in 2009?
Give a very brief answer. 1.12. What is the ratio of the Gross intake ratio(%) of Cote d'Ivoire in 1999 to that in 2009?
Provide a short and direct response. 0.86. What is the ratio of the Gross intake ratio(%) in Namibia in 1999 to that in 2009?
Your response must be concise. 1.12. What is the ratio of the Gross intake ratio(%) of High income: nonOECD in 2000 to that in 2002?
Provide a succinct answer. 0.95. What is the ratio of the Gross intake ratio(%) in Armenia in 2000 to that in 2002?
Provide a short and direct response. 0.93. What is the ratio of the Gross intake ratio(%) of Cote d'Ivoire in 2000 to that in 2002?
Provide a succinct answer. 0.94. What is the ratio of the Gross intake ratio(%) of Namibia in 2000 to that in 2002?
Offer a terse response. 0.99. What is the ratio of the Gross intake ratio(%) in High income: nonOECD in 2000 to that in 2003?
Keep it short and to the point. 0.96. What is the ratio of the Gross intake ratio(%) in Armenia in 2000 to that in 2003?
Offer a very short reply. 1.02. What is the ratio of the Gross intake ratio(%) of Cote d'Ivoire in 2000 to that in 2003?
Offer a very short reply. 0.87. What is the ratio of the Gross intake ratio(%) of High income: nonOECD in 2000 to that in 2006?
Offer a very short reply. 0.96. What is the ratio of the Gross intake ratio(%) in Armenia in 2000 to that in 2006?
Offer a terse response. 0.9. What is the ratio of the Gross intake ratio(%) of Cote d'Ivoire in 2000 to that in 2006?
Your answer should be very brief. 0.99. What is the ratio of the Gross intake ratio(%) of Namibia in 2000 to that in 2006?
Your answer should be compact. 1.07. What is the ratio of the Gross intake ratio(%) in High income: nonOECD in 2000 to that in 2008?
Offer a very short reply. 0.95. What is the ratio of the Gross intake ratio(%) of Armenia in 2000 to that in 2008?
Ensure brevity in your answer.  0.99. What is the ratio of the Gross intake ratio(%) in Cote d'Ivoire in 2000 to that in 2008?
Your response must be concise. 0.83. What is the ratio of the Gross intake ratio(%) in Namibia in 2000 to that in 2008?
Your response must be concise. 1.09. What is the ratio of the Gross intake ratio(%) of High income: nonOECD in 2000 to that in 2009?
Ensure brevity in your answer.  0.93. What is the ratio of the Gross intake ratio(%) of Armenia in 2000 to that in 2009?
Your answer should be very brief. 0.97. What is the ratio of the Gross intake ratio(%) of Cote d'Ivoire in 2000 to that in 2009?
Give a very brief answer. 0.84. What is the ratio of the Gross intake ratio(%) in Namibia in 2000 to that in 2009?
Offer a very short reply. 1.11. What is the ratio of the Gross intake ratio(%) in High income: nonOECD in 2002 to that in 2003?
Your answer should be very brief. 1.01. What is the ratio of the Gross intake ratio(%) of Armenia in 2002 to that in 2003?
Keep it short and to the point. 1.09. What is the ratio of the Gross intake ratio(%) of Cote d'Ivoire in 2002 to that in 2003?
Your answer should be very brief. 0.92. What is the ratio of the Gross intake ratio(%) in Namibia in 2002 to that in 2003?
Give a very brief answer. 1.01. What is the ratio of the Gross intake ratio(%) of High income: nonOECD in 2002 to that in 2006?
Your answer should be compact. 1.01. What is the ratio of the Gross intake ratio(%) in Armenia in 2002 to that in 2006?
Keep it short and to the point. 0.96. What is the ratio of the Gross intake ratio(%) in Cote d'Ivoire in 2002 to that in 2006?
Your answer should be compact. 1.06. What is the ratio of the Gross intake ratio(%) of Namibia in 2002 to that in 2006?
Provide a short and direct response. 1.08. What is the ratio of the Gross intake ratio(%) in Armenia in 2002 to that in 2008?
Your answer should be very brief. 1.06. What is the ratio of the Gross intake ratio(%) in Cote d'Ivoire in 2002 to that in 2008?
Offer a terse response. 0.88. What is the ratio of the Gross intake ratio(%) of Namibia in 2002 to that in 2008?
Provide a short and direct response. 1.1. What is the ratio of the Gross intake ratio(%) of High income: nonOECD in 2002 to that in 2009?
Your answer should be very brief. 0.98. What is the ratio of the Gross intake ratio(%) of Armenia in 2002 to that in 2009?
Offer a very short reply. 1.04. What is the ratio of the Gross intake ratio(%) in Cote d'Ivoire in 2002 to that in 2009?
Provide a succinct answer. 0.9. What is the ratio of the Gross intake ratio(%) in Namibia in 2002 to that in 2009?
Ensure brevity in your answer.  1.12. What is the ratio of the Gross intake ratio(%) of Armenia in 2003 to that in 2006?
Ensure brevity in your answer.  0.88. What is the ratio of the Gross intake ratio(%) in Cote d'Ivoire in 2003 to that in 2006?
Offer a very short reply. 1.15. What is the ratio of the Gross intake ratio(%) of Namibia in 2003 to that in 2006?
Make the answer very short. 1.07. What is the ratio of the Gross intake ratio(%) in High income: nonOECD in 2003 to that in 2008?
Offer a terse response. 0.99. What is the ratio of the Gross intake ratio(%) in Armenia in 2003 to that in 2008?
Your answer should be very brief. 0.97. What is the ratio of the Gross intake ratio(%) in Cote d'Ivoire in 2003 to that in 2008?
Keep it short and to the point. 0.96. What is the ratio of the Gross intake ratio(%) in Namibia in 2003 to that in 2008?
Give a very brief answer. 1.09. What is the ratio of the Gross intake ratio(%) in Armenia in 2003 to that in 2009?
Make the answer very short. 0.95. What is the ratio of the Gross intake ratio(%) in Namibia in 2003 to that in 2009?
Ensure brevity in your answer.  1.11. What is the ratio of the Gross intake ratio(%) in High income: nonOECD in 2006 to that in 2008?
Your answer should be compact. 0.99. What is the ratio of the Gross intake ratio(%) of Armenia in 2006 to that in 2008?
Provide a succinct answer. 1.1. What is the ratio of the Gross intake ratio(%) of Cote d'Ivoire in 2006 to that in 2008?
Offer a very short reply. 0.83. What is the ratio of the Gross intake ratio(%) of Namibia in 2006 to that in 2008?
Keep it short and to the point. 1.02. What is the ratio of the Gross intake ratio(%) of High income: nonOECD in 2006 to that in 2009?
Ensure brevity in your answer.  0.97. What is the ratio of the Gross intake ratio(%) in Armenia in 2006 to that in 2009?
Keep it short and to the point. 1.08. What is the ratio of the Gross intake ratio(%) of Cote d'Ivoire in 2006 to that in 2009?
Offer a terse response. 0.85. What is the ratio of the Gross intake ratio(%) in Namibia in 2006 to that in 2009?
Provide a short and direct response. 1.04. What is the ratio of the Gross intake ratio(%) in High income: nonOECD in 2008 to that in 2009?
Keep it short and to the point. 0.99. What is the ratio of the Gross intake ratio(%) in Armenia in 2008 to that in 2009?
Your response must be concise. 0.98. What is the ratio of the Gross intake ratio(%) in Cote d'Ivoire in 2008 to that in 2009?
Keep it short and to the point. 1.02. What is the ratio of the Gross intake ratio(%) in Namibia in 2008 to that in 2009?
Your answer should be very brief. 1.02. What is the difference between the highest and the second highest Gross intake ratio(%) of High income: nonOECD?
Ensure brevity in your answer.  1.29. What is the difference between the highest and the second highest Gross intake ratio(%) of Armenia?
Your answer should be compact. 4.19. What is the difference between the highest and the second highest Gross intake ratio(%) in Cote d'Ivoire?
Your answer should be compact. 1.22. What is the difference between the highest and the second highest Gross intake ratio(%) of Namibia?
Keep it short and to the point. 0.23. What is the difference between the highest and the lowest Gross intake ratio(%) of High income: nonOECD?
Offer a terse response. 7.22. What is the difference between the highest and the lowest Gross intake ratio(%) of Armenia?
Offer a terse response. 16.84. What is the difference between the highest and the lowest Gross intake ratio(%) of Cote d'Ivoire?
Ensure brevity in your answer.  12.49. What is the difference between the highest and the lowest Gross intake ratio(%) in Namibia?
Offer a terse response. 11.36. 